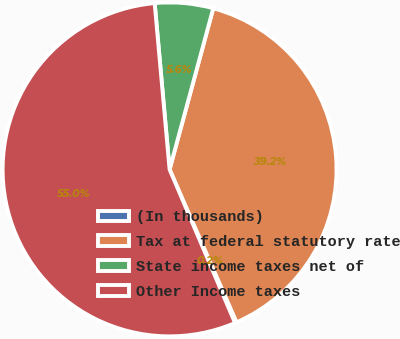Convert chart to OTSL. <chart><loc_0><loc_0><loc_500><loc_500><pie_chart><fcel>(In thousands)<fcel>Tax at federal statutory rate<fcel>State income taxes net of<fcel>Other Income taxes<nl><fcel>0.16%<fcel>39.21%<fcel>5.64%<fcel>54.99%<nl></chart> 